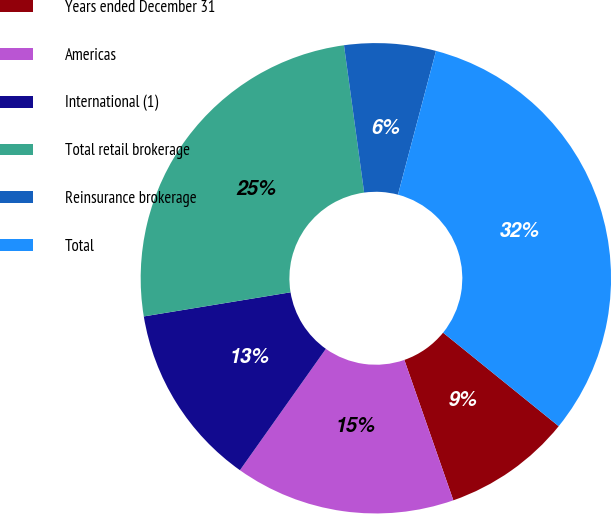<chart> <loc_0><loc_0><loc_500><loc_500><pie_chart><fcel>Years ended December 31<fcel>Americas<fcel>International (1)<fcel>Total retail brokerage<fcel>Reinsurance brokerage<fcel>Total<nl><fcel>8.83%<fcel>15.15%<fcel>12.6%<fcel>25.43%<fcel>6.28%<fcel>31.71%<nl></chart> 